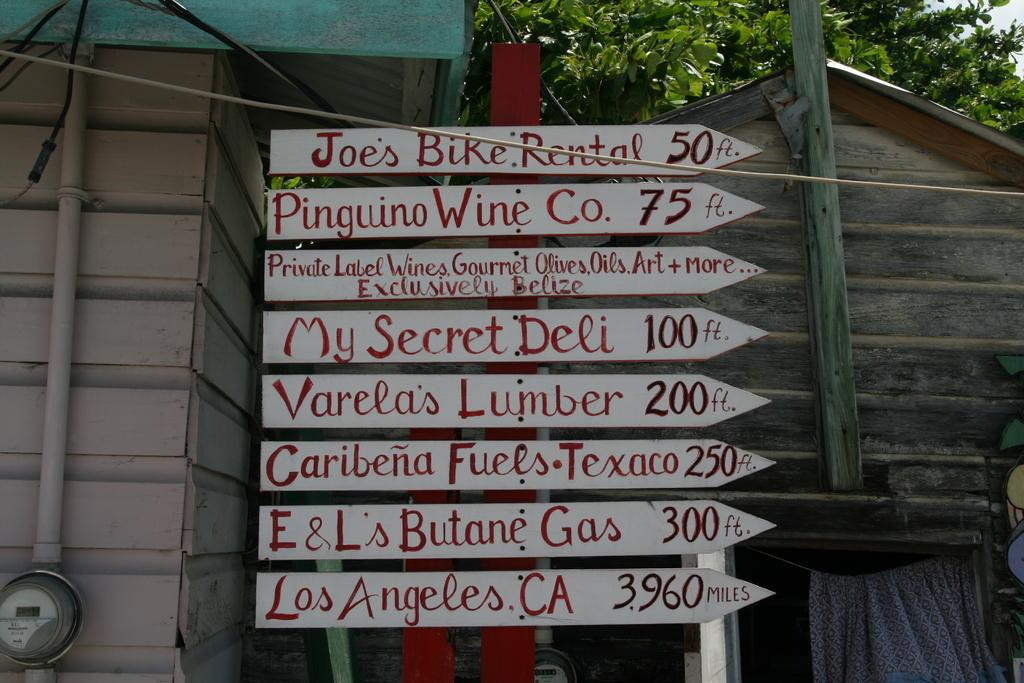What is located in the center of the image? There are sign boards in the center of the image. What can be seen in the background of the image? There are houses and a tree in the background of the image. What is visible in the sky in the image? The sky is visible in the background of the image. Can you see a cow pushing a sailboat in the image? No, there is no cow or sailboat present in the image. 